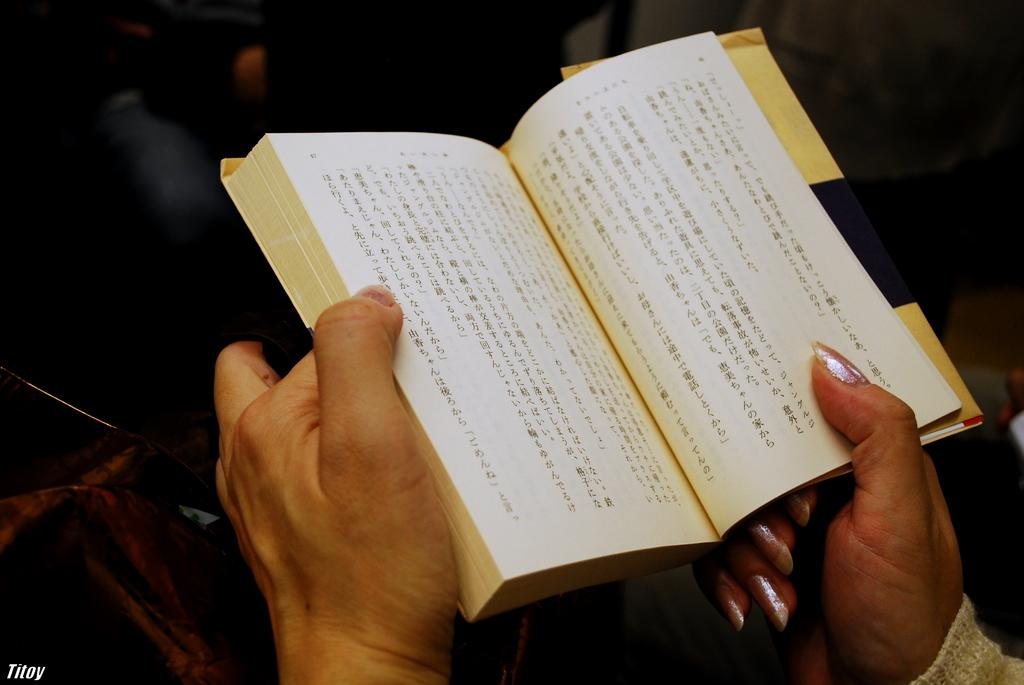What body part is visible in the image? There are a person's hands in the image. What is the person holding in their hands? The person is holding a book. What can be seen on the papers in the image? There are words written on the papers in the image. How would you describe the lighting in the image? The background of the image is dark. Can you identify any additional features in the image? There is a watermark visible in the image. Can you tell me how many pencils are being shaken in the office in the image? There is no office, pencils, or shaking depicted in the image. 